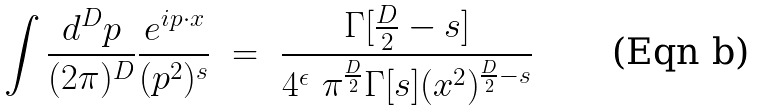Convert formula to latex. <formula><loc_0><loc_0><loc_500><loc_500>\int \frac { d ^ { D } p } { ( 2 \pi ) ^ { D } } \frac { e ^ { i p \cdot x } } { ( p ^ { 2 } ) ^ { s } } \ = \ \frac { \Gamma [ \frac { D } { 2 } - s ] } { 4 ^ { \epsilon } \ \pi ^ { \frac { D } { 2 } } \Gamma [ s ] ( x ^ { 2 } ) ^ { \frac { D } { 2 } - s } }</formula> 